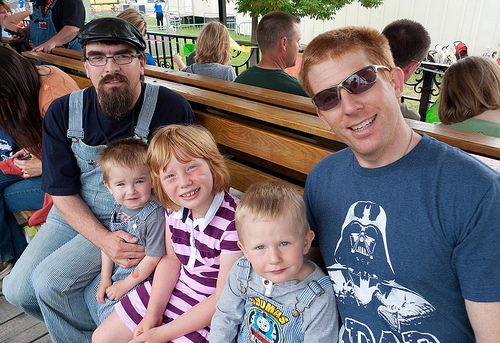<image>
Is the beard on the hat? No. The beard is not positioned on the hat. They may be near each other, but the beard is not supported by or resting on top of the hat. Is there a man behind the boy? Yes. From this viewpoint, the man is positioned behind the boy, with the boy partially or fully occluding the man. Is there a fence behind the bench? Yes. From this viewpoint, the fence is positioned behind the bench, with the bench partially or fully occluding the fence. Where is the girl baby in relation to the man? Is it to the right of the man? Yes. From this viewpoint, the girl baby is positioned to the right side relative to the man. 